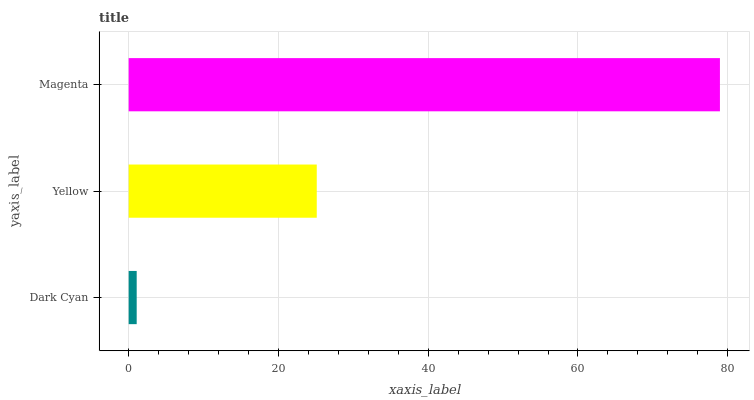Is Dark Cyan the minimum?
Answer yes or no. Yes. Is Magenta the maximum?
Answer yes or no. Yes. Is Yellow the minimum?
Answer yes or no. No. Is Yellow the maximum?
Answer yes or no. No. Is Yellow greater than Dark Cyan?
Answer yes or no. Yes. Is Dark Cyan less than Yellow?
Answer yes or no. Yes. Is Dark Cyan greater than Yellow?
Answer yes or no. No. Is Yellow less than Dark Cyan?
Answer yes or no. No. Is Yellow the high median?
Answer yes or no. Yes. Is Yellow the low median?
Answer yes or no. Yes. Is Magenta the high median?
Answer yes or no. No. Is Dark Cyan the low median?
Answer yes or no. No. 